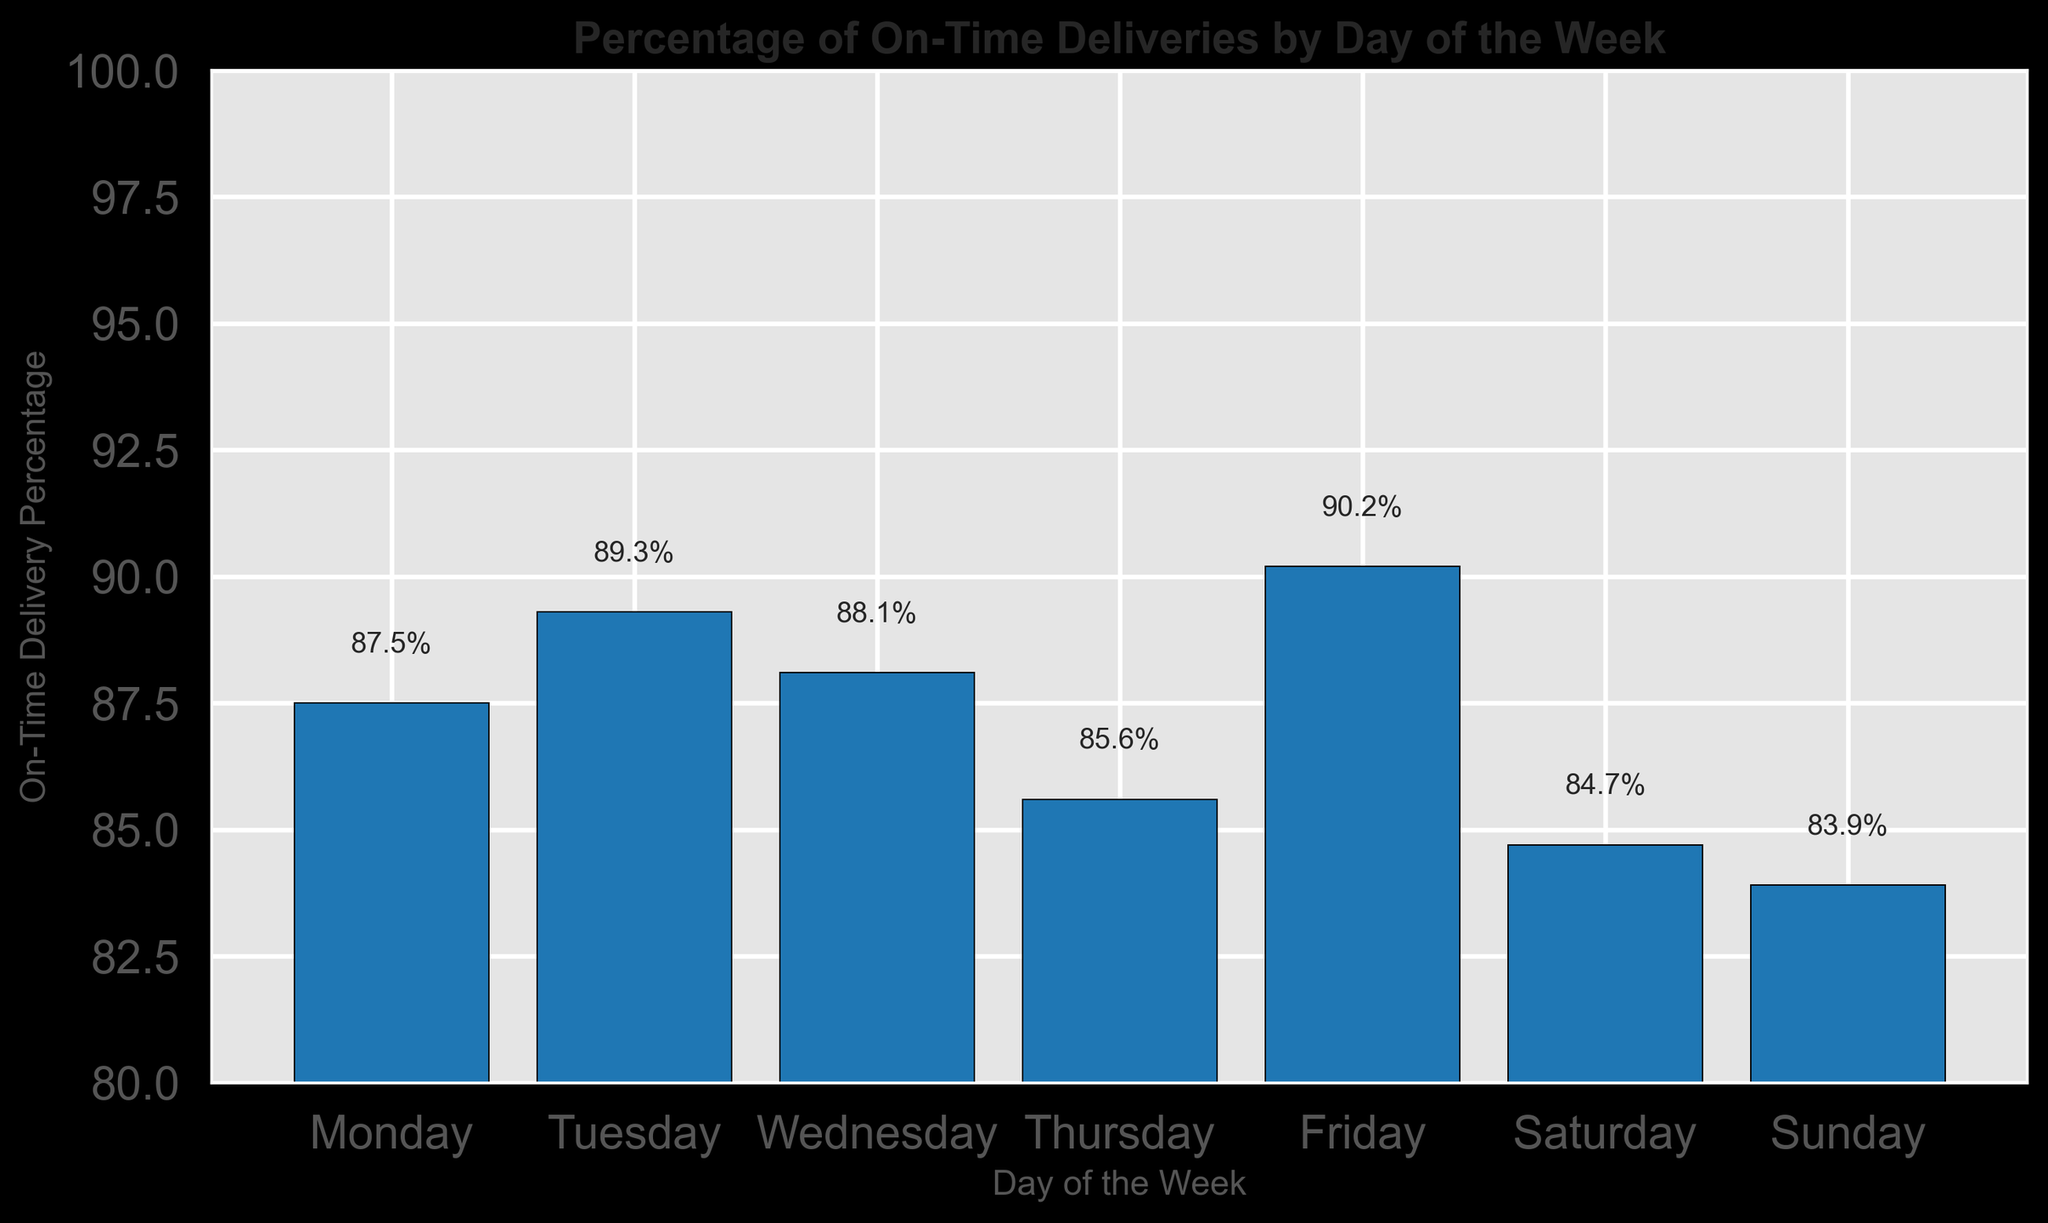What's the average percentage of on-time deliveries from Monday to Friday? To find the average percentage of on-time deliveries from Monday to Friday, sum the percentages for these days: (87.5 + 89.3 + 88.1 + 85.6 + 90.2) = 440.7. Then, divide by the number of days (5) to get 440.7 / 5 = 88.14%
Answer: 88.14% Which day has the lowest on-time delivery percentage? Identify the shortest bar in the chart that corresponds to the lowest percentage value. From the figure, Sunday has the shortest bar with an on-time delivery percentage of 83.9%.
Answer: Sunday Is the on-time delivery percentage higher on Wednesday or Thursday? Compare the heights of the bars for Wednesday and Thursday. The on-time delivery percentage is 88.1% on Wednesday and 85.6% on Thursday, so Wednesday is higher.
Answer: Wednesday What's the difference in on-time delivery percentage between the highest and the lowest day? Identify the highest and lowest percentages. The highest is Friday at 90.2% and the lowest is Sunday at 83.9%. Calculate the difference: 90.2 - 83.9 = 6.3%.
Answer: 6.3% Which days have an on-time delivery percentage greater than 88%? Identify the bars that exceed the 88% level. From the chart, the days are Tuesday (89.3%) and Friday (90.2%).
Answer: Tuesday, Friday What is the visual pattern of the bars as we move from Monday to Sunday? Observe the decreasing pattern of the bar heights as we move from Monday to Sunday, with occasional rises like on Tuesday and Friday. Overall, the heights show a general downward trend.
Answer: Downward trend Which day has an approximately mid-range on-time delivery percentage? Find the day whose bar height is median when considering all days. Wednesday has an on-time delivery percentage of 88.1%, falling in the middle of the range.
Answer: Wednesday Are there more days with an on-time delivery percentage below 85% or above 85%? Count the days within each range. Days with below 85% are Saturday (84.7%) and Sunday (83.9%), and days above 85% are Monday, Tuesday, Wednesday, Thursday, and Friday. There are 2 days below and 5 days above.
Answer: Above 85% From the visual perspective, how many bars show a percentage above 86%? Count the bars whose heights are above the 86% marker. The days are Monday, Tuesday, Wednesday, Thursday, and Friday.
Answer: 5 What's the total percentage of on-time deliveries for the weekend (Saturday and Sunday)? Sum the percentages for Saturday and Sunday: 84.7 + 83.9 = 168.6%.
Answer: 168.6% 